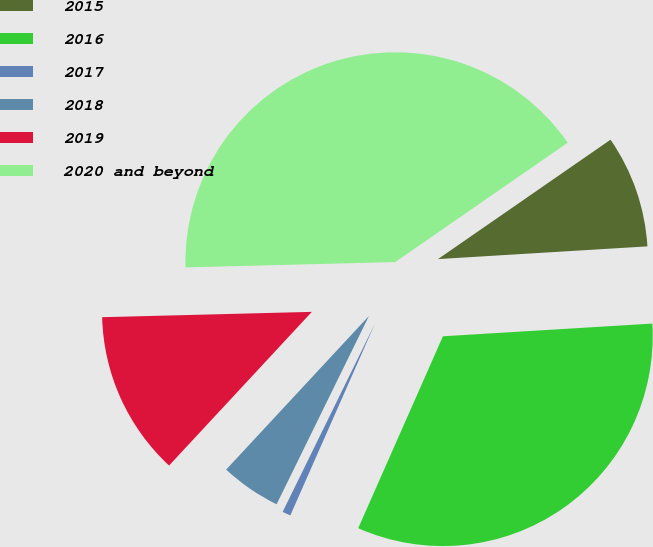<chart> <loc_0><loc_0><loc_500><loc_500><pie_chart><fcel>2015<fcel>2016<fcel>2017<fcel>2018<fcel>2019<fcel>2020 and beyond<nl><fcel>8.67%<fcel>32.58%<fcel>0.64%<fcel>4.66%<fcel>12.68%<fcel>40.77%<nl></chart> 